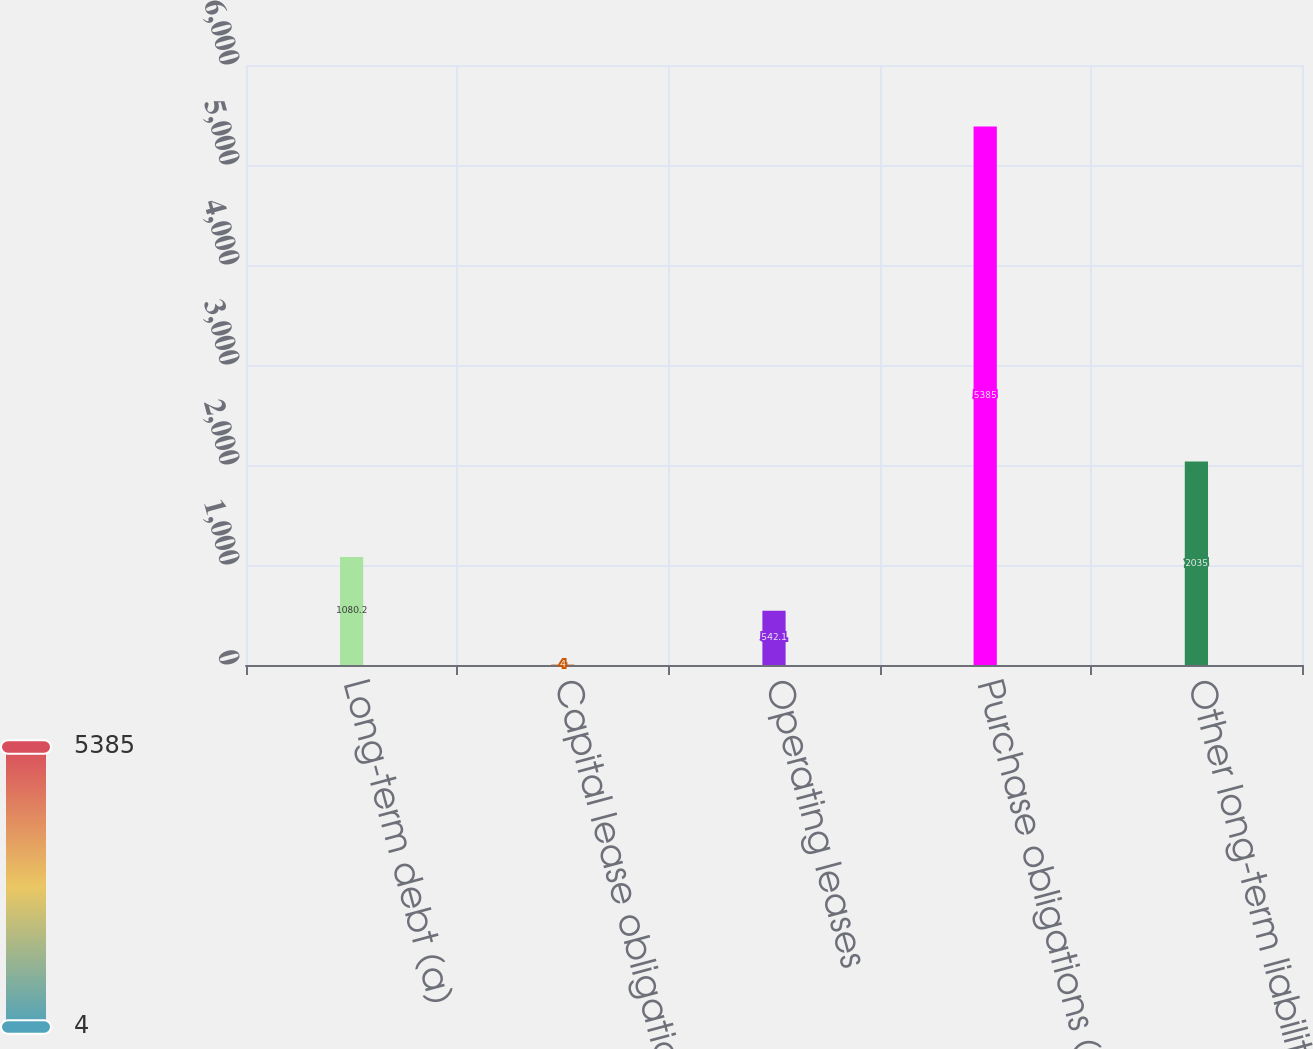Convert chart. <chart><loc_0><loc_0><loc_500><loc_500><bar_chart><fcel>Long-term debt (a)<fcel>Capital lease obligations<fcel>Operating leases<fcel>Purchase obligations (b)<fcel>Other long-term liabilities<nl><fcel>1080.2<fcel>4<fcel>542.1<fcel>5385<fcel>2035<nl></chart> 